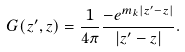<formula> <loc_0><loc_0><loc_500><loc_500>G ( { z } ^ { \prime } , { z } ) = \frac { 1 } { 4 \pi } \frac { { - e ^ { { m _ { k } } { \left | { { z } ^ { \prime } - { z } } \right | } } } } { { \left | { { z } ^ { \prime } - { z } } \right | } } .</formula> 